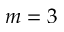<formula> <loc_0><loc_0><loc_500><loc_500>m = 3</formula> 